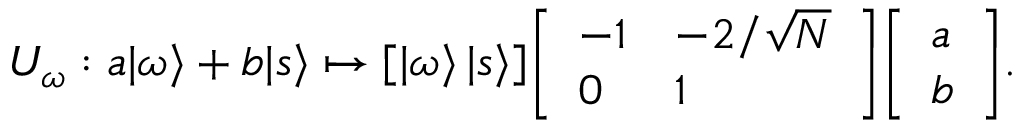Convert formula to latex. <formula><loc_0><loc_0><loc_500><loc_500>U _ { \omega } \colon a | \omega \rangle + b | s \rangle \mapsto [ | \omega \rangle \, | s \rangle ] { \left [ \begin{array} { l l } { - 1 } & { - 2 / { \sqrt { N } } } \\ { 0 } & { 1 } \end{array} \right ] } { \left [ \begin{array} { l } { a } \\ { b } \end{array} \right ] } .</formula> 